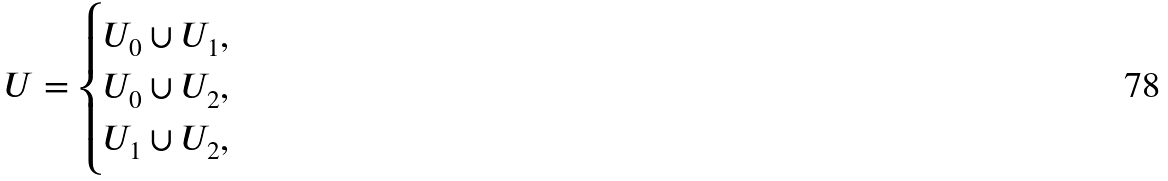<formula> <loc_0><loc_0><loc_500><loc_500>U = \begin{cases} U _ { 0 } \cup U _ { 1 } , & \\ U _ { 0 } \cup U _ { 2 } , & \\ U _ { 1 } \cup U _ { 2 } , & \\ \end{cases}</formula> 